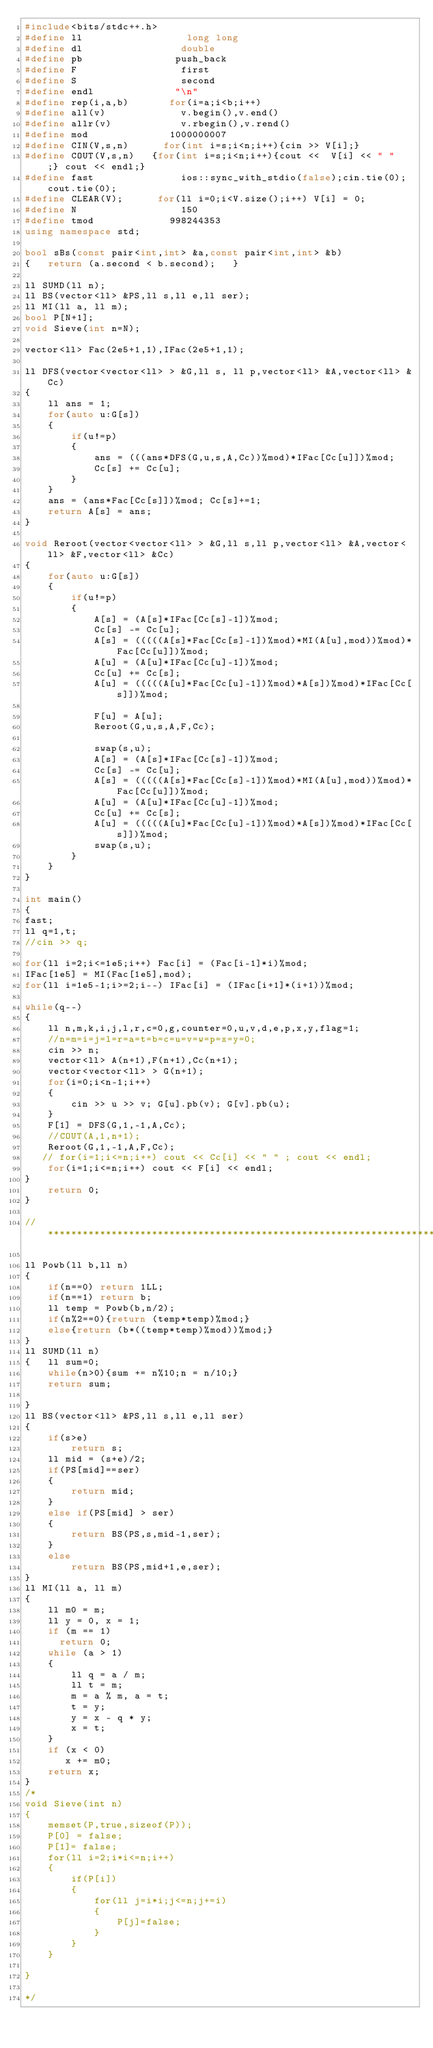Convert code to text. <code><loc_0><loc_0><loc_500><loc_500><_C++_>#include<bits/stdc++.h>
#define ll                  long long
#define dl                 double
#define pb                push_back
#define F                  first
#define S                  second
#define endl              "\n"
#define rep(i,a,b)       for(i=a;i<b;i++)
#define all(v)             v.begin(),v.end()
#define allr(v)            v.rbegin(),v.rend()
#define mod              1000000007
#define CIN(V,s,n)      for(int i=s;i<n;i++){cin >> V[i];}
#define COUT(V,s,n)   {for(int i=s;i<n;i++){cout <<  V[i] << " "  ;} cout << endl;}
#define fast               ios::sync_with_stdio(false);cin.tie(0);cout.tie(0);
#define CLEAR(V);      for(ll i=0;i<V.size();i++) V[i] = 0;
#define N                  150
#define tmod             998244353
using namespace std;

bool sBs(const pair<int,int> &a,const pair<int,int> &b)
{   return (a.second < b.second);   }

ll SUMD(ll n);
ll BS(vector<ll> &PS,ll s,ll e,ll ser);
ll MI(ll a, ll m);
bool P[N+1];
void Sieve(int n=N);

vector<ll> Fac(2e5+1,1),IFac(2e5+1,1);

ll DFS(vector<vector<ll> > &G,ll s, ll p,vector<ll> &A,vector<ll> &Cc)
{
    ll ans = 1;
    for(auto u:G[s])
    {
        if(u!=p)
        {
            ans = (((ans*DFS(G,u,s,A,Cc))%mod)*IFac[Cc[u]])%mod;
            Cc[s] += Cc[u];
        }
    }
    ans = (ans*Fac[Cc[s]])%mod; Cc[s]+=1;
    return A[s] = ans;
}

void Reroot(vector<vector<ll> > &G,ll s,ll p,vector<ll> &A,vector<ll> &F,vector<ll> &Cc)
{
    for(auto u:G[s])
    {
        if(u!=p)
        {
            A[s] = (A[s]*IFac[Cc[s]-1])%mod;
            Cc[s] -= Cc[u];
            A[s] = (((((A[s]*Fac[Cc[s]-1])%mod)*MI(A[u],mod))%mod)*Fac[Cc[u]])%mod;
            A[u] = (A[u]*IFac[Cc[u]-1])%mod;
            Cc[u] += Cc[s];
            A[u] = (((((A[u]*Fac[Cc[u]-1])%mod)*A[s])%mod)*IFac[Cc[s]])%mod;

            F[u] = A[u];
            Reroot(G,u,s,A,F,Cc);

            swap(s,u);
            A[s] = (A[s]*IFac[Cc[s]-1])%mod;
            Cc[s] -= Cc[u];
            A[s] = (((((A[s]*Fac[Cc[s]-1])%mod)*MI(A[u],mod))%mod)*Fac[Cc[u]])%mod;
            A[u] = (A[u]*IFac[Cc[u]-1])%mod;
            Cc[u] += Cc[s];
            A[u] = (((((A[u]*Fac[Cc[u]-1])%mod)*A[s])%mod)*IFac[Cc[s]])%mod;
            swap(s,u);
        }
    }
}

int main()
{
fast;
ll q=1,t;
//cin >> q;

for(ll i=2;i<=1e5;i++) Fac[i] = (Fac[i-1]*i)%mod;
IFac[1e5] = MI(Fac[1e5],mod);
for(ll i=1e5-1;i>=2;i--) IFac[i] = (IFac[i+1]*(i+1))%mod;

while(q--)
{
    ll n,m,k,i,j,l,r,c=0,g,counter=0,u,v,d,e,p,x,y,flag=1;
    //n=m=i=j=l=r=a=t=b=c=u=v=w=p=x=y=0;
    cin >> n;
    vector<ll> A(n+1),F(n+1),Cc(n+1);
    vector<vector<ll> > G(n+1);
    for(i=0;i<n-1;i++)
    {
        cin >> u >> v; G[u].pb(v); G[v].pb(u);
    }
    F[1] = DFS(G,1,-1,A,Cc);
    //COUT(A,1,n+1);
    Reroot(G,1,-1,A,F,Cc);
   // for(i=1;i<=n;i++) cout << Cc[i] << " " ; cout << endl;
    for(i=1;i<=n;i++) cout << F[i] << endl;
}
    return 0;
}

//*****************************************************************************************************************************************

ll Powb(ll b,ll n)
{
    if(n==0) return 1LL;
    if(n==1) return b;
    ll temp = Powb(b,n/2);
    if(n%2==0){return (temp*temp)%mod;}
    else{return (b*((temp*temp)%mod))%mod;}
}
ll SUMD(ll n)
{   ll sum=0;
    while(n>0){sum += n%10;n = n/10;}
    return sum;

}
ll BS(vector<ll> &PS,ll s,ll e,ll ser)
{
    if(s>e)
        return s;
    ll mid = (s+e)/2;
    if(PS[mid]==ser)
    {
        return mid;
    }
    else if(PS[mid] > ser)
    {
        return BS(PS,s,mid-1,ser);
    }
    else
        return BS(PS,mid+1,e,ser);
}
ll MI(ll a, ll m)
{
    ll m0 = m;
    ll y = 0, x = 1;
    if (m == 1)
      return 0;
    while (a > 1)
    {
        ll q = a / m;
        ll t = m;
        m = a % m, a = t;
        t = y;
        y = x - q * y;
        x = t;
    }
    if (x < 0)
       x += m0;
    return x;
}
/*
void Sieve(int n)
{
    memset(P,true,sizeof(P));
    P[0] = false;
    P[1]= false;
    for(ll i=2;i*i<=n;i++)
    {
        if(P[i])
        {
            for(ll j=i*i;j<=n;j+=i)
            {
                P[j]=false;
            }
        }
    }

}

*/
</code> 